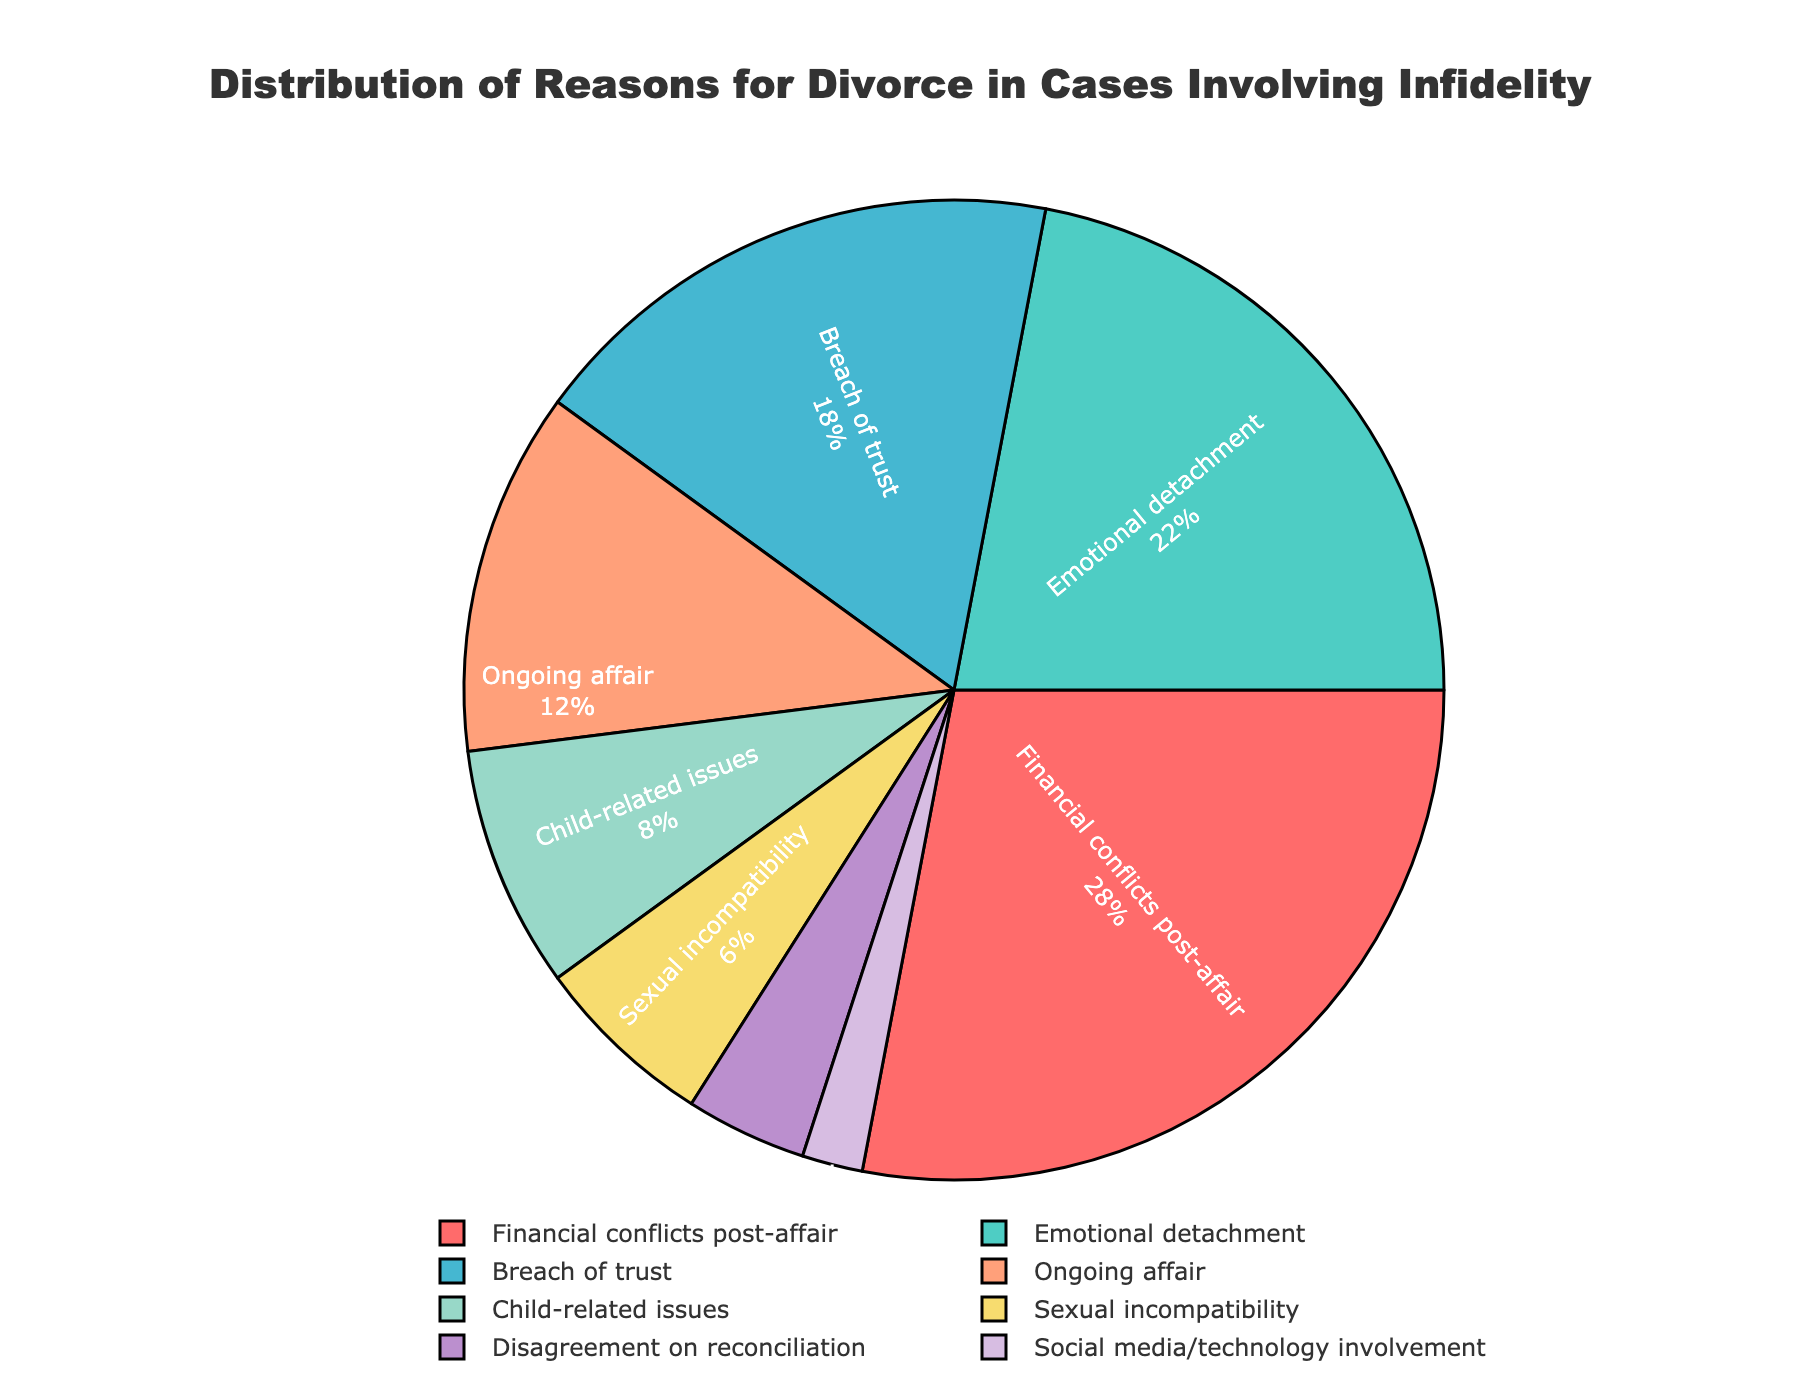What is the most common reason for divorce in cases involving infidelity? The pie chart shows that the segment labeled "Financial conflicts post-affair" has the largest percentage.
Answer: Financial conflicts post-affair What is the combined percentage for reasons related to financial conflicts and emotional detachment? The percentages for "Financial conflicts post-affair" and "Emotional detachment" are 28% and 22%, respectively. Adding them gives 28% + 22% = 50%.
Answer: 50% Which reason has a greater percentage: ongoing affair or breach of trust? Comparing the percentages, "Breach of trust" has 18% and "Ongoing affair" has 12%. Therefore, "Breach of trust" has a greater percentage.
Answer: Breach of trust How much higher is the percentage of child-related issues compared to social media/technology involvement? The percentage for "Child-related issues" is 8% and for "Social media/technology involvement" is 2%. The difference is 8% - 2% = 6%.
Answer: 6% Are there any reasons with a percentage lower than 5%? The pie chart shows that "Disagreement on reconciliation" has 4% and "Social media/technology involvement" has 2%, both of which are below 5%.
Answer: Yes What is the percentage difference between the most common and least common reasons for divorce? The most common reason is "Financial conflicts post-affair" with 28%, and the least common is "Social media/technology involvement" with 2%. The difference is 28% - 2% = 26%.
Answer: 26% Combine the percentages of reasons that relate to emotional factors rather than specific incidents (emotional detachment, breach of trust, and sexual incompatibility). Summing the percentages for "Emotional detachment" (22%), "Breach of trust" (18%), and "Sexual incompatibility" (6%) gives 22% + 18% + 6% = 46%.
Answer: 46% What is the percentage of reasons that are directly related to the continuation of the affair (ongoing affair and financial conflicts post-affair)? The percentages for "Ongoing affair" and "Financial conflicts post-affair" are 12% and 28%, respectively. Adding them gives 12% + 28% = 40%.
Answer: 40% Which segments of the pie chart are represented with cooler colors (such as blue or green)? Observing the colors, "Emotional detachment" is represented with green, and "Breach of trust" with a lighter blue color.
Answer: Emotional detachment, Breach of trust 